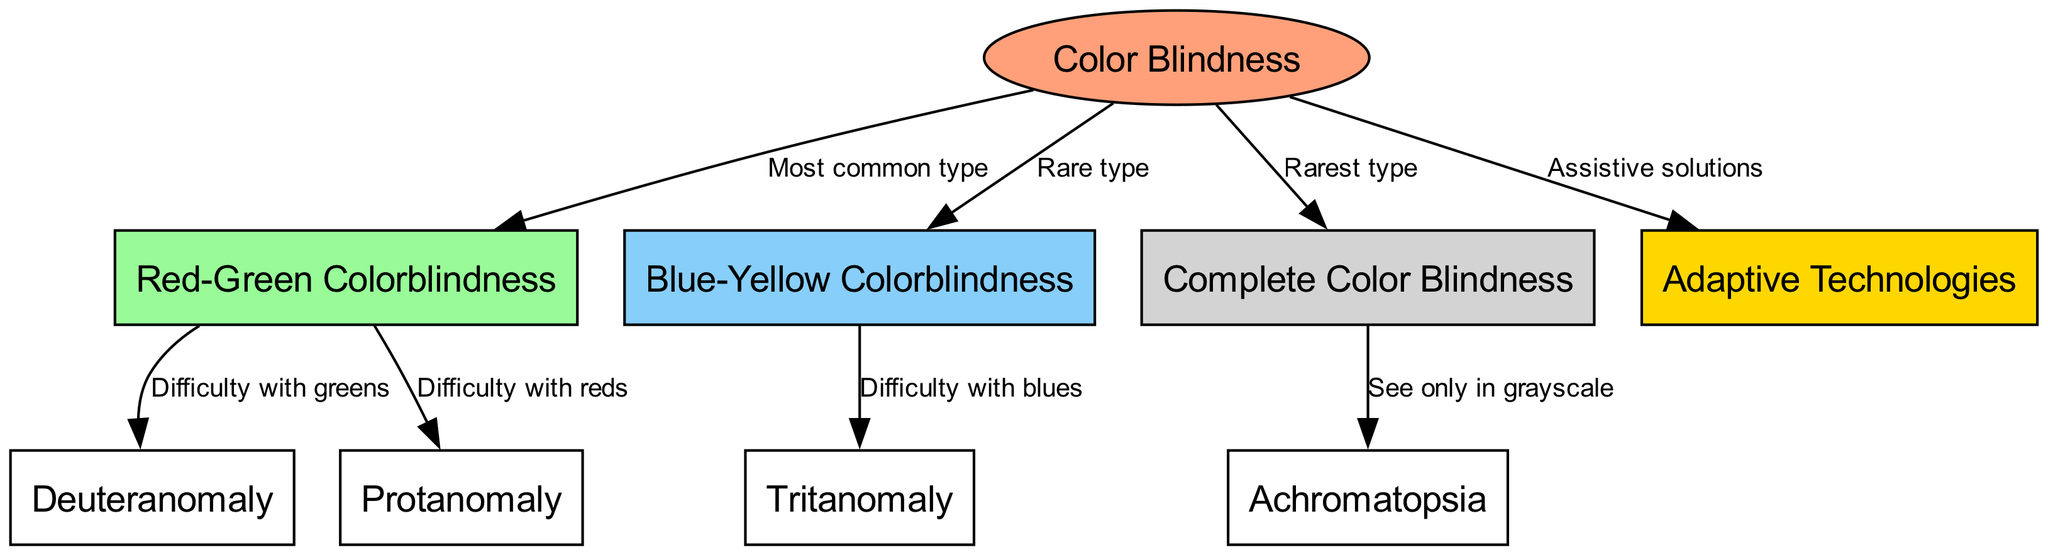What is the most common type of color blindness? The diagram states that "Red-Green Colorblindness" is the most common type, as indicated by the edge leading from the "Color Blindness" node to the "Red-Green Colorblindness" node labeled "Most common type."
Answer: Red-Green Colorblindness How many types of color blindness are represented in the diagram? By examining the nodes in the diagram, we see there are 7 types of color blindness: Red-Green, Blue-Yellow, Complete, Deuteranomaly, Protanomaly, Tritanomaly, and Achromatopsia.
Answer: 7 What type of color blindness has difficulty with greens? The "Deuteranomaly" node is connected to the "Red-Green Colorblindness" node, with an edge labeled "Difficulty with greens," indicating that this type specifically relates to difficulties in perceiving greens.
Answer: Deuteranomaly What is the rarest type of color blindness? The edge from the "Color Blindness" node to the "Complete Color Blindness" node is labeled "Rarest type," indicating that this represents the rarest form among the types listed in the diagram.
Answer: Complete Color Blindness Which type of color blindness is related to seeing only in grayscale? The edge leading from the "Complete Color Blindness" node to the "Achromatopsia" node is labeled "See only in grayscale," demonstrating that this type entails seeing only shades of gray.
Answer: Achromatopsia What is a common feature shared by all color blindness types according to the diagram? The diagram shows an edge from "Color Blindness" to "Adaptive Technologies," indicating that all types of color blindness share the feature of having available assistive solutions.
Answer: Assistive solutions What type of color blindness has difficulty with reds? The "Protanomaly" node is specifically linked to the "Red-Green Colorblindness" node with an edge marked "Difficulty with reds," which clarifies that this type has issues with perceiving red colors.
Answer: Protanomaly What type of color blindness involves difficulty with blues? The "Tritanomaly" node is connected to the "Blue-Yellow Colorblindness" node with an edge labeled "Difficulty with blues," highlighting its difficulty in perceiving blue hues.
Answer: Tritanomaly 